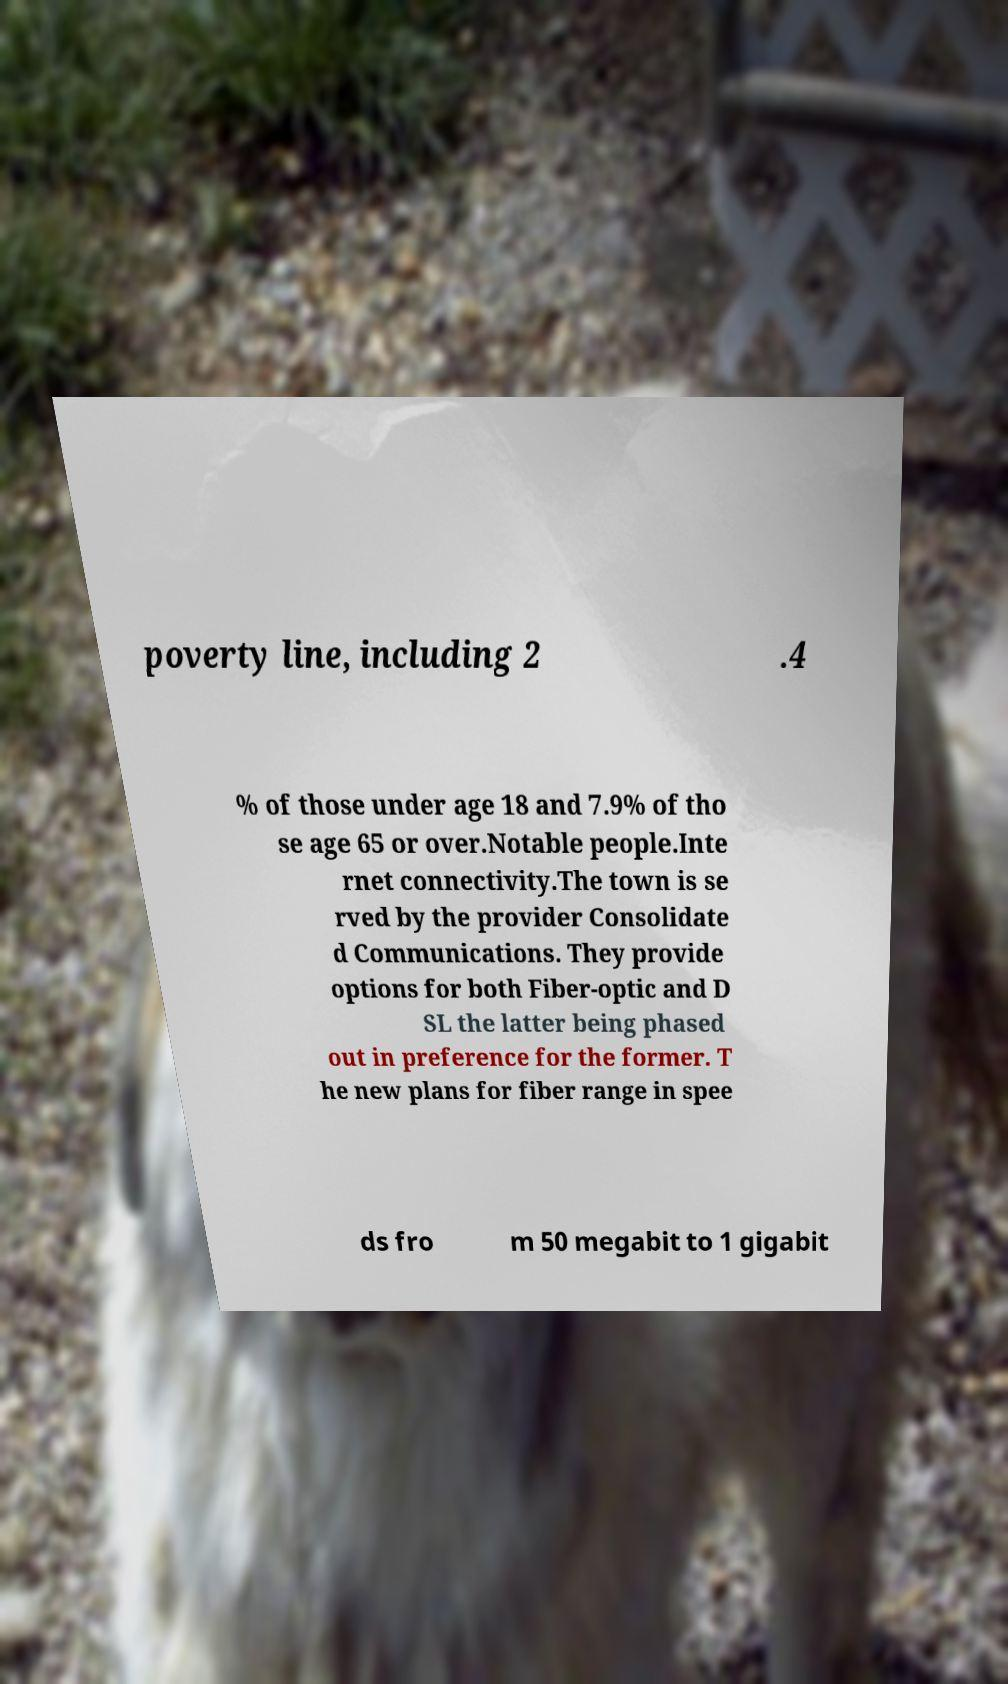I need the written content from this picture converted into text. Can you do that? poverty line, including 2 .4 % of those under age 18 and 7.9% of tho se age 65 or over.Notable people.Inte rnet connectivity.The town is se rved by the provider Consolidate d Communications. They provide options for both Fiber-optic and D SL the latter being phased out in preference for the former. T he new plans for fiber range in spee ds fro m 50 megabit to 1 gigabit 